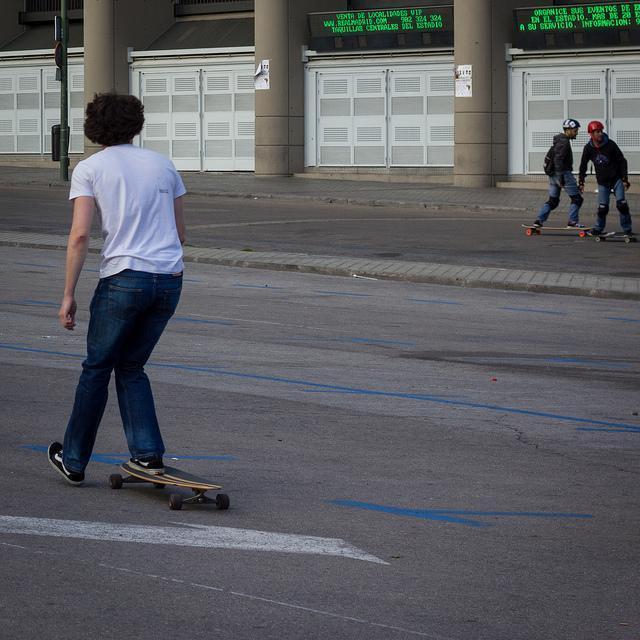How many skateboarders are not wearing safety equipment?
Give a very brief answer. 1. How many boards are shown?
Give a very brief answer. 3. How many children are in the picture?
Give a very brief answer. 3. How many people appear in this photo that are not the focus?
Give a very brief answer. 2. How many skateboards are in this picture?
Give a very brief answer. 3. How many windows are there?
Give a very brief answer. 0. How many people are in the scene?
Give a very brief answer. 3. How many people are in the picture?
Give a very brief answer. 3. 